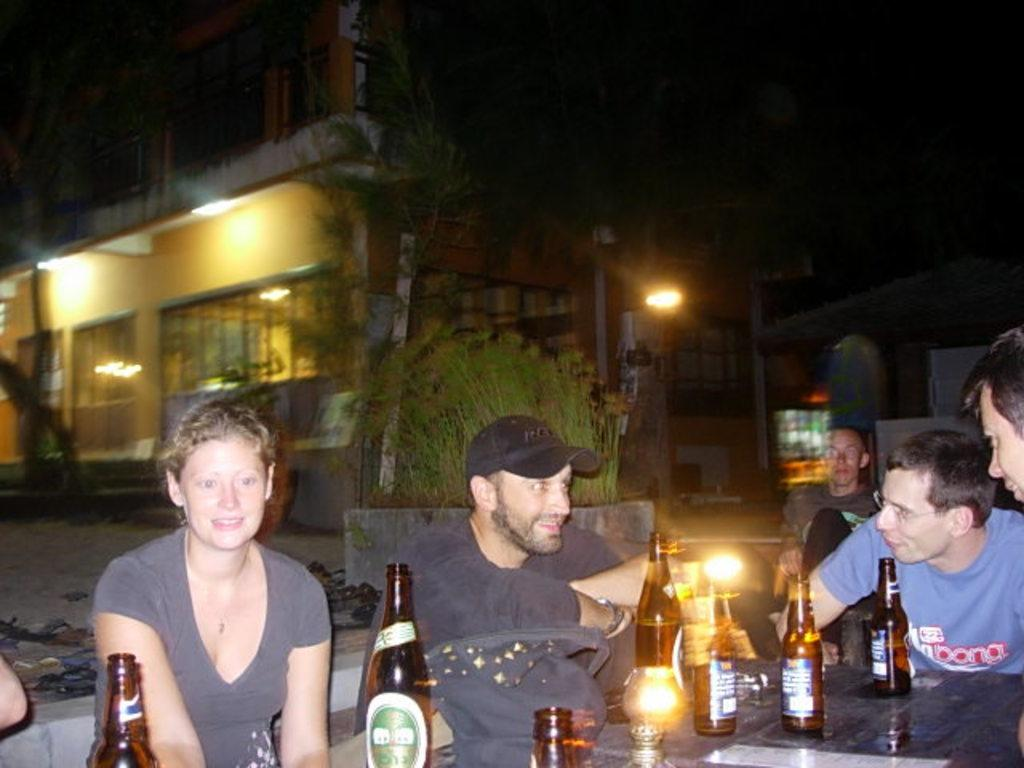What are the people in the image doing? There is a group of people sitting in chairs in the image. What can be seen on the table in the image? There are wine bottles and glasses on the table in the image. What is visible in the background of the image? There is a building, plants, and light visible in the background of the image. How many lizards are crawling on the table in the image? There are no lizards present in the image; the table only has wine bottles and glasses. What type of cactus can be seen in the background of the image? There is no cactus present in the image; the background features a building, plants, and light. 